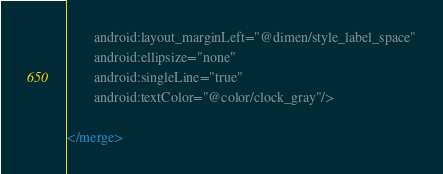Convert code to text. <code><loc_0><loc_0><loc_500><loc_500><_XML_>        android:layout_marginLeft="@dimen/style_label_space"
        android:ellipsize="none"
        android:singleLine="true"
        android:textColor="@color/clock_gray"/>

</merge>

</code> 